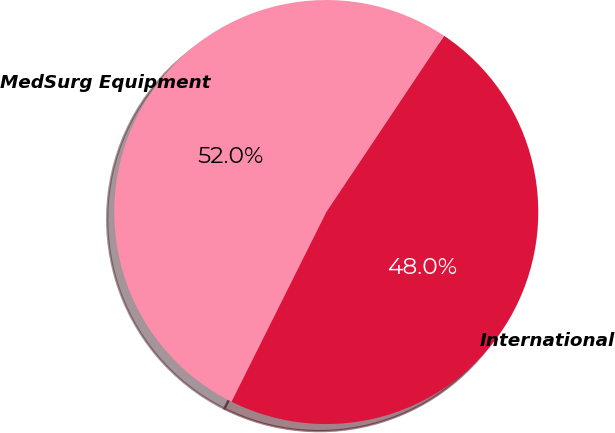Convert chart. <chart><loc_0><loc_0><loc_500><loc_500><pie_chart><fcel>International<fcel>MedSurg Equipment<nl><fcel>48.0%<fcel>52.0%<nl></chart> 